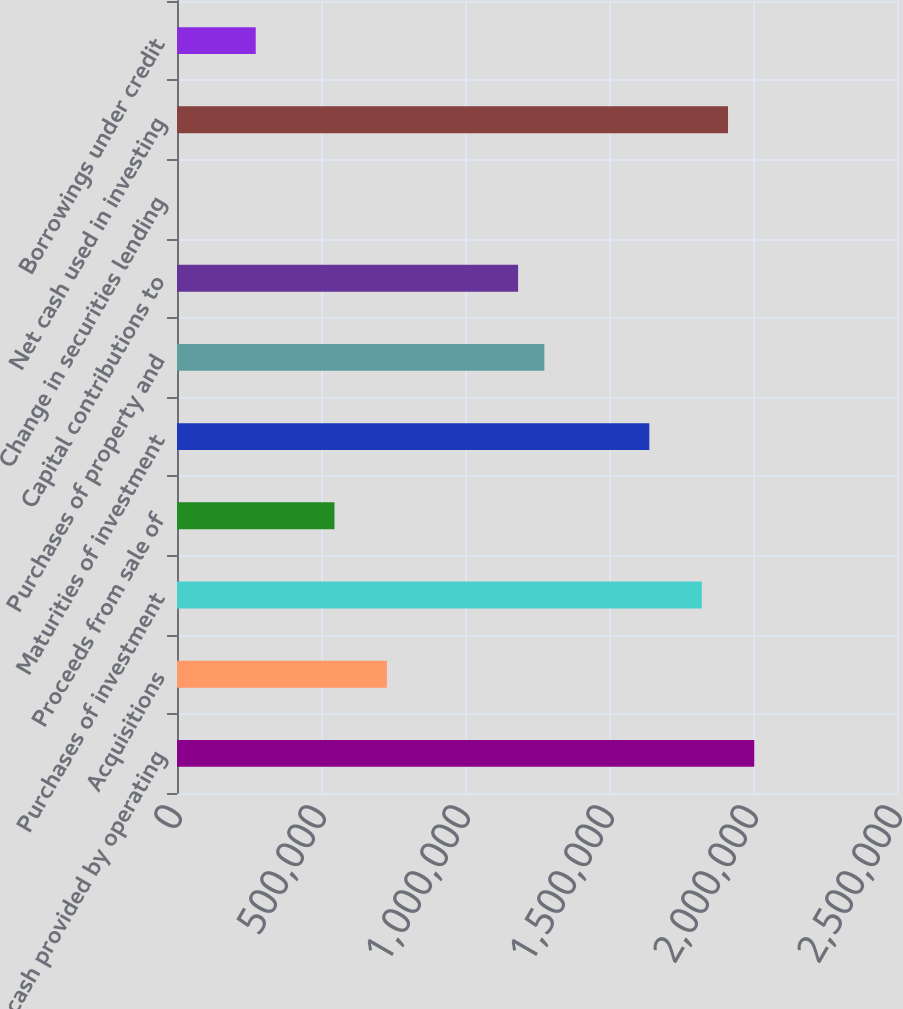Convert chart. <chart><loc_0><loc_0><loc_500><loc_500><bar_chart><fcel>Net cash provided by operating<fcel>Acquisitions<fcel>Purchases of investment<fcel>Proceeds from sale of<fcel>Maturities of investment<fcel>Purchases of property and<fcel>Capital contributions to<fcel>Change in securities lending<fcel>Net cash used in investing<fcel>Borrowings under credit<nl><fcel>2.0044e+06<fcel>728872<fcel>1.82218e+06<fcel>546654<fcel>1.63996e+06<fcel>1.27553e+06<fcel>1.18442e+06<fcel>0.6<fcel>1.91329e+06<fcel>273327<nl></chart> 